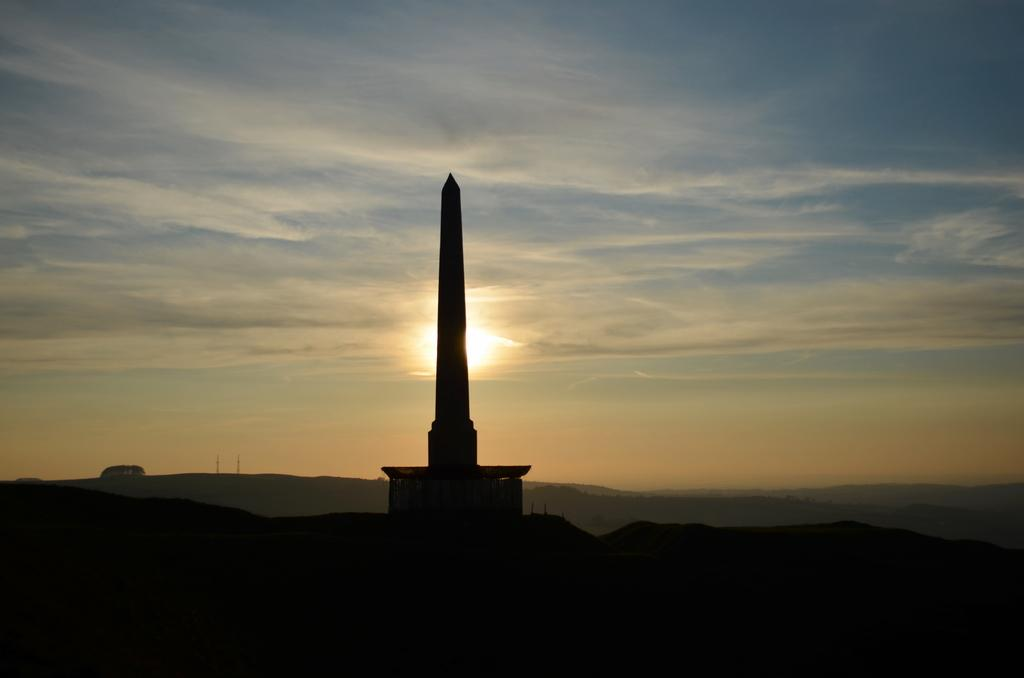What is the main structure in the center of the image? There is a tower in the center of the image. What type of natural features can be seen in the image? There are hills in the image. What is visible in the sky in the background? There are clouds in the sky in the background. What time of day is depicted in the image? The image depicts a sunset. Can you see any poisonous plants near the tower in the image? There is no mention of any plants, poisonous or otherwise, in the image. 